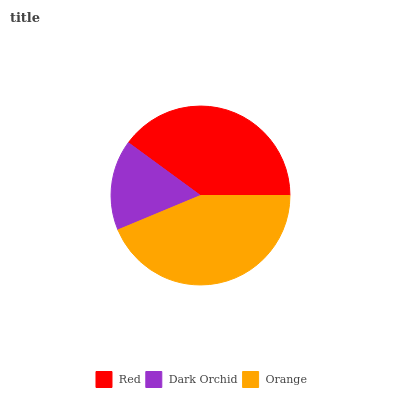Is Dark Orchid the minimum?
Answer yes or no. Yes. Is Orange the maximum?
Answer yes or no. Yes. Is Orange the minimum?
Answer yes or no. No. Is Dark Orchid the maximum?
Answer yes or no. No. Is Orange greater than Dark Orchid?
Answer yes or no. Yes. Is Dark Orchid less than Orange?
Answer yes or no. Yes. Is Dark Orchid greater than Orange?
Answer yes or no. No. Is Orange less than Dark Orchid?
Answer yes or no. No. Is Red the high median?
Answer yes or no. Yes. Is Red the low median?
Answer yes or no. Yes. Is Orange the high median?
Answer yes or no. No. Is Orange the low median?
Answer yes or no. No. 